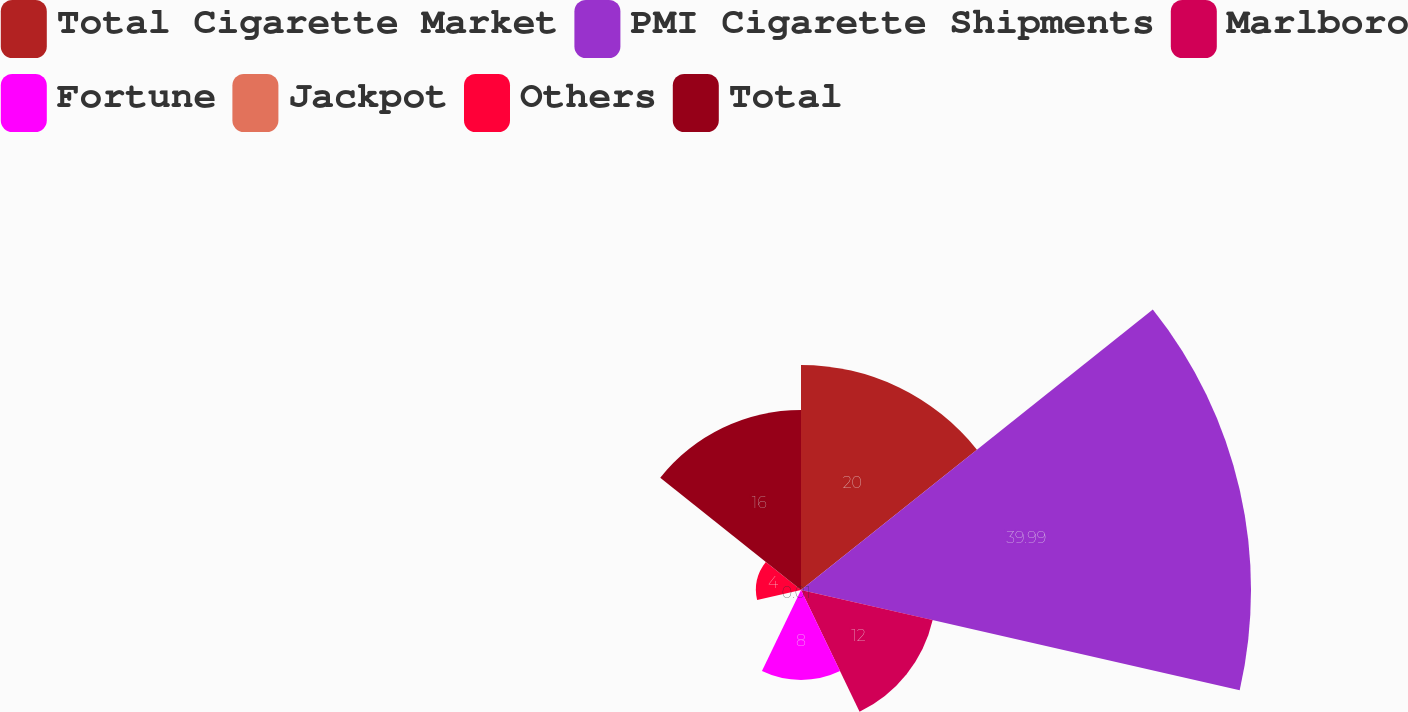Convert chart to OTSL. <chart><loc_0><loc_0><loc_500><loc_500><pie_chart><fcel>Total Cigarette Market<fcel>PMI Cigarette Shipments<fcel>Marlboro<fcel>Fortune<fcel>Jackpot<fcel>Others<fcel>Total<nl><fcel>20.0%<fcel>39.99%<fcel>12.0%<fcel>8.0%<fcel>0.01%<fcel>4.0%<fcel>16.0%<nl></chart> 